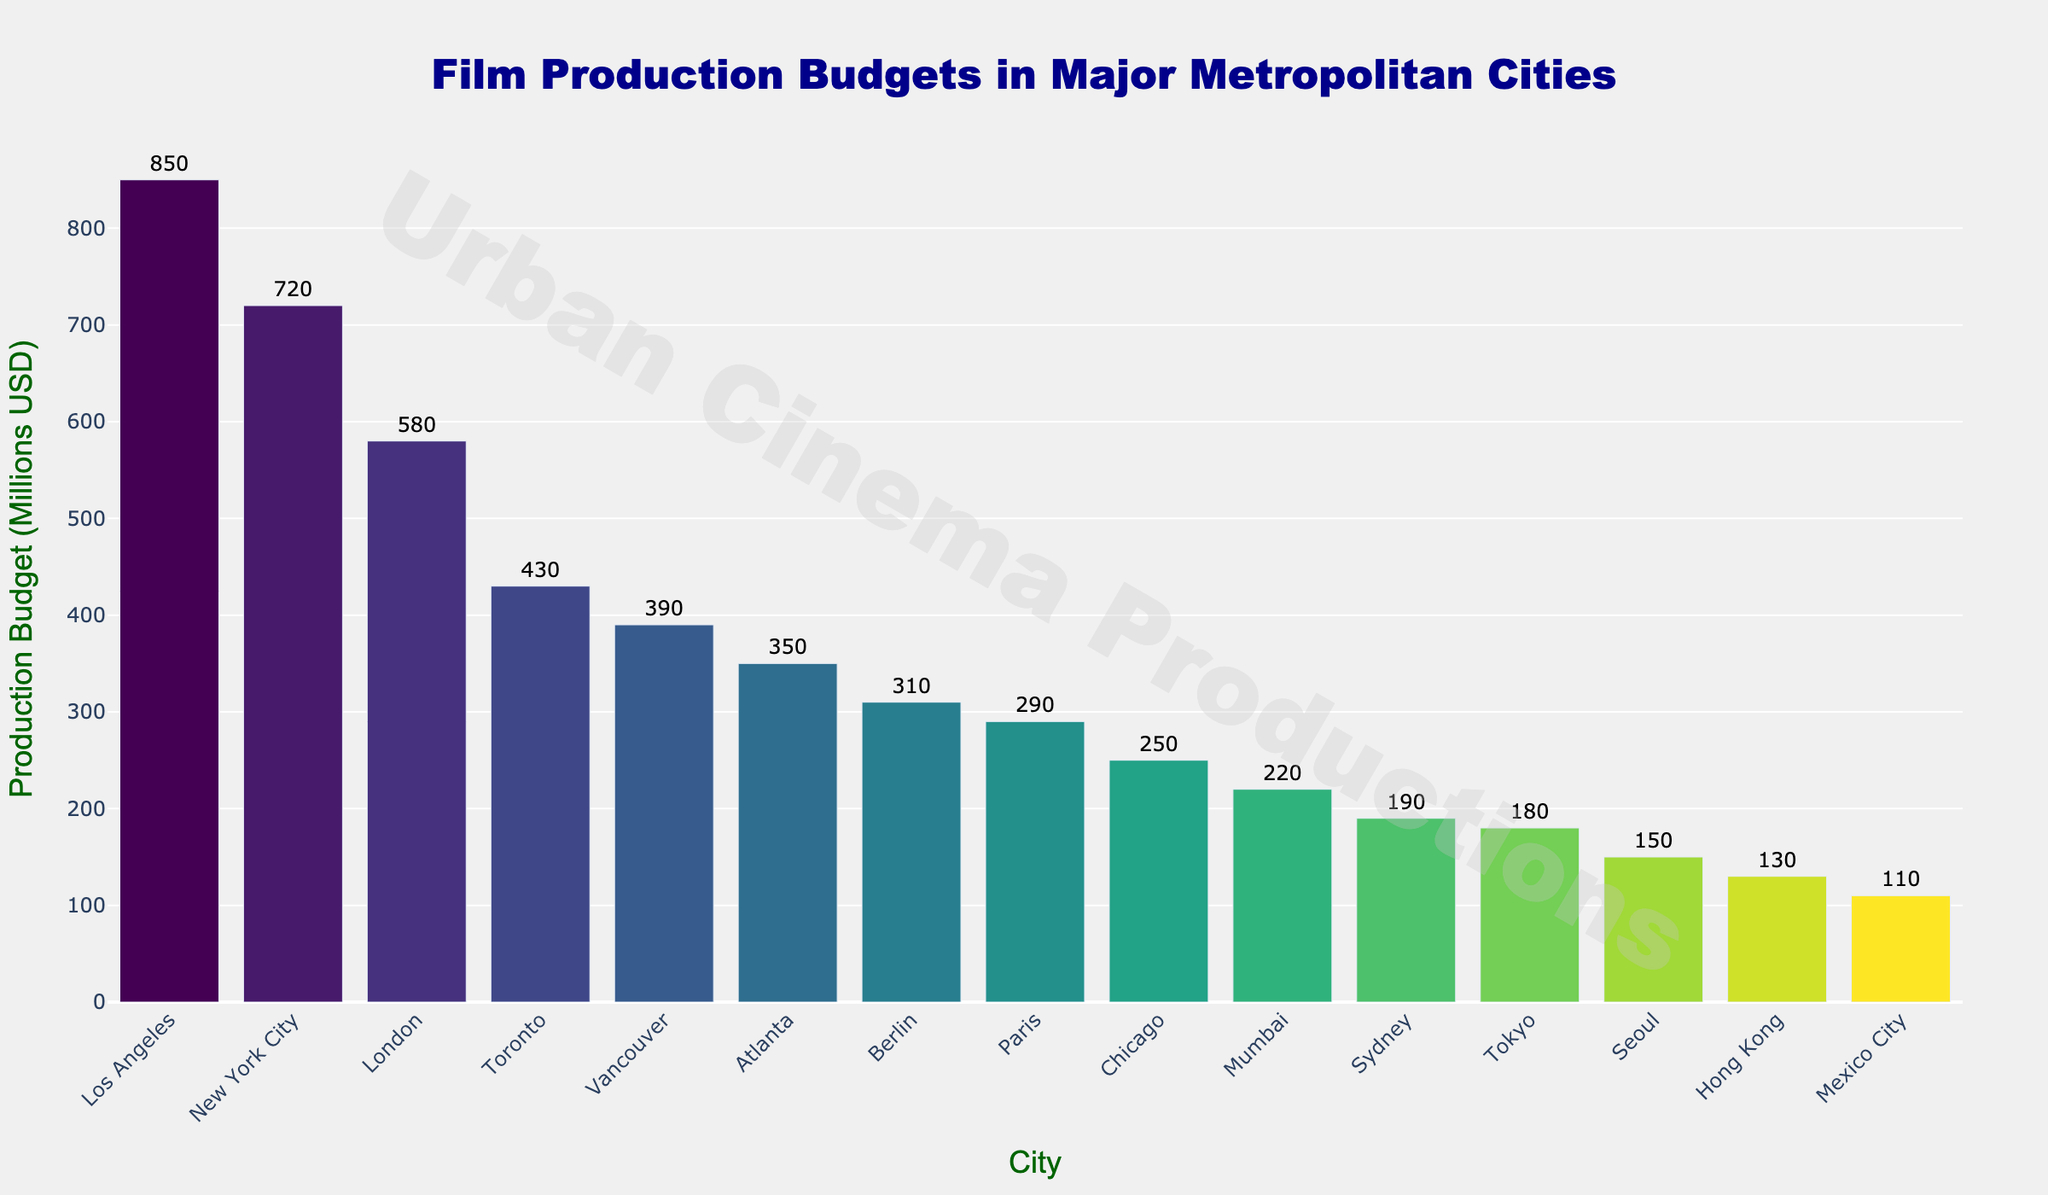Which city has the highest film production budget? By looking at the heights of the bars, Los Angeles has the tallest bar, indicating it has the highest film production budget.
Answer: Los Angeles What's the combined production budget of New York City and Toronto? New York City has a budget of 720M and Toronto has 430M. The sum is 720 + 430 = 1150M.
Answer: 1150M Between Paris and Berlin, which city has a higher film production budget? Berlin has a budget of 310M and Paris has a budget of 290M. Comparing these values, Berlin's budget is higher.
Answer: Berlin What is the difference in production budgets between London and Vancouver? London has a budget of 580M and Vancouver has 390M. The difference is 580 - 390 = 190M.
Answer: 190M Which city has the lowest film production budget? By looking at the shortest bar in the chart, Mexico City has the lowest film production budget.
Answer: Mexico City How many cities have a production budget exceeding 300M? The cities with budgets exceeding 300M are Los Angeles, New York City, London, Toronto, and Vancouver, tallying to 5 cities.
Answer: 5 What is the total production budget for the bottom three cities? The bottom three cities are Tokyo (180M), Seoul (150M), and Hong Kong (130M). Their combined budget is 180 + 150 + 130 = 460M.
Answer: 460M Which city has a higher production budget: Sydney or Mumbai? Sydney has a budget of 190M and Mumbai has 220M. Comparing these values, Mumbai's budget is higher.
Answer: Mumbai What's the average production budget of all the cities listed? Sum all the budgets (850 + 720 + 580 + 430 + 390 + 350 + 310 + 290 + 250 + 220 + 190 + 180 + 150 + 130 + 110 = 5250). There are 15 cities. Average is 5250 / 15 = 350M.
Answer: 350M Is there a significant visual drop in budgets between any consecutive cities? There is a noticeable drop between Toronto (430M) and Vancouver (390M), where the visual height of the bars shows a clear gap.
Answer: Yes, between Toronto and Vancouver 